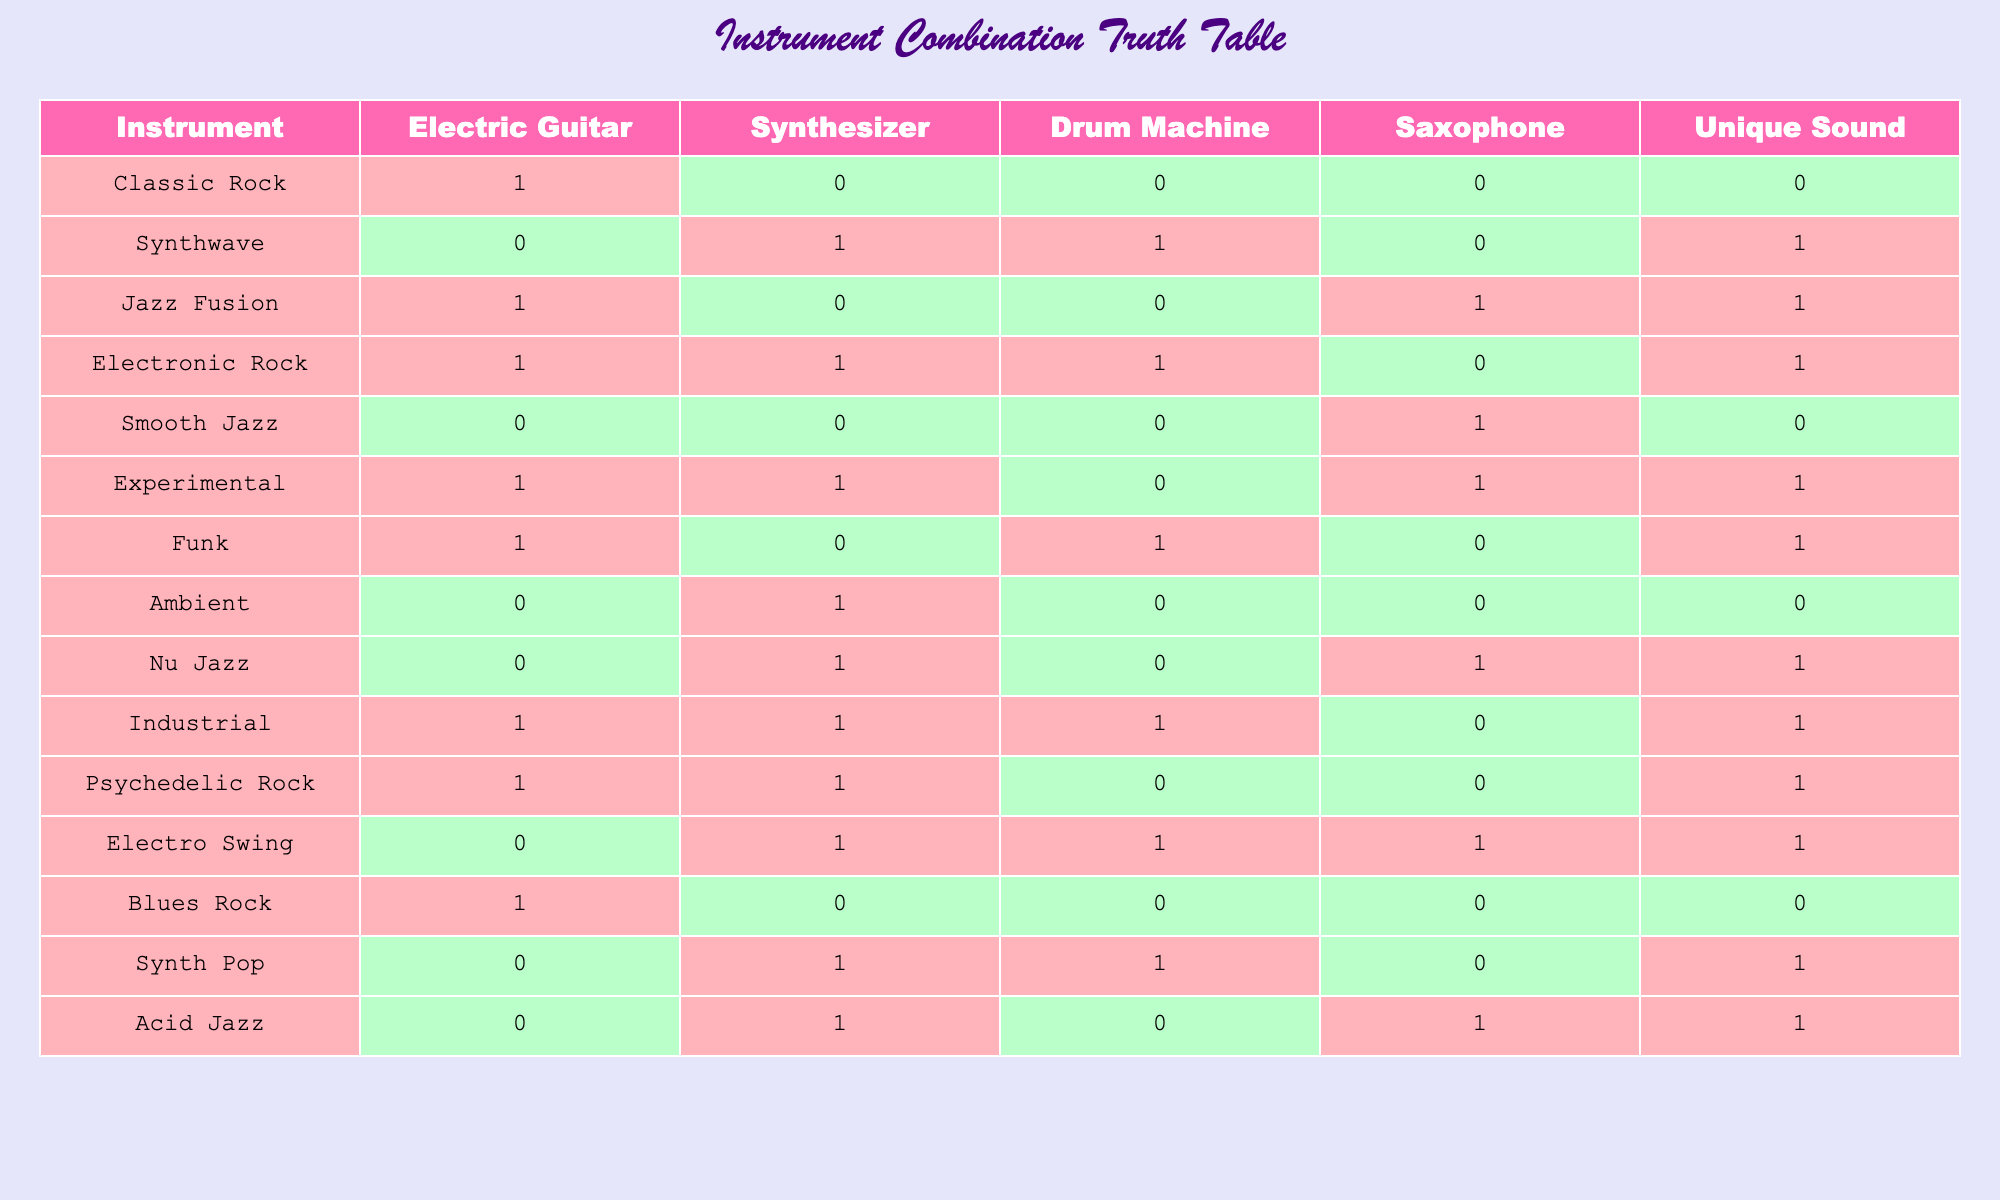What is the unique sound associated with the genre Smooth Jazz? In the table, the row corresponding to Smooth Jazz shows a Unique Sound value of 0. This means there is no unique sound associated with this genre.
Answer: 0 Are there any genres that combine both the Synthesizer and Drum Machine? Yes, by looking at the rows, we can see that Synthwave, Electronic Rock, Electro Swing, and Acid Jazz all have values of 1 for both Synthesizer and Drum Machine, indicating they combine these two instruments.
Answer: Yes What genres have a unique sound and include Saxophone? We can find these genres by checking the Unique Sound column for a value of 1 and also checking if the Saxophone column has a value of 1. The genres that meet this criteria are Jazz Fusion, Experimental, Nu Jazz, and Electro Swing.
Answer: Jazz Fusion, Experimental, Nu Jazz, Electro Swing How many genres feature the Electric Guitar but do not have a unique sound? To answer this, we look for rows where the Electric Guitar has a value of 1 and Unique Sound has a value of 0. The only genre that fits this description is Blues Rock, so there is 1 genre.
Answer: 1 Which instrument type was involved in the creation of the most unique sounds? To determine this, we can count how many times each instrument appears in genres that have a Unique Sound value of 1. Electric Guitar appears in 6 genres, Synthesizer in 5, Drum Machine in 5, and Saxophone in 3 genres with unique sounds. The Electric Guitar has the highest count.
Answer: Electric Guitar What is the total number of genres that feature the Synthesizer? In the table, we can count the number of genres where the Synthesizer has a value of 1. These genres are Synthwave, Electronic Rock, Ambient, Electro Swing, Synth Pop, Acid Jazz, and Nu Jazz, making a total of 7 genres.
Answer: 7 Is it true that all genres that feature the Drum Machine also have a unique sound? To evaluate this, we check all the rows where the Drum Machine has a value of 1 and see if Unique Sound is also 1 in those rows. The genres that have a Drum Machine include Synthwave, Electronic Rock, Funk, Industrial, and Electro Swing. Among them, only Smooth Jazz and the three with Drum Machine do not have a unique sound. Thus, it is false.
Answer: No Which two genres have the same instrument combination but different unique sound results? We look for rows with identical instrument columns (the same values across Electric Guitar, Synthesizer, Drum Machine, and Saxophone) but differing Unique Sound values. Electric Guitar, Drum Machine, and Saxophone have the same for Jazz Fusion and Experimental (1, 0, 1, 1) with a different Unique Sound (1 and 1), which means both genres show the same instruments but are distinct in sound.
Answer: Jazz Fusion and Experimental 